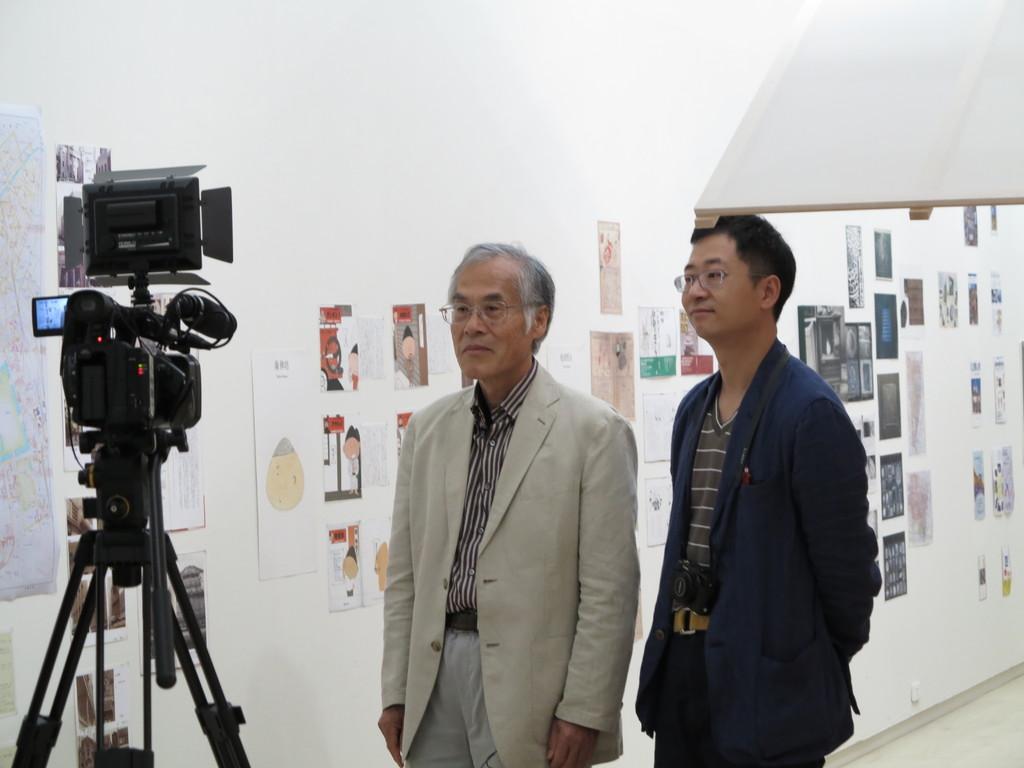How would you summarize this image in a sentence or two? In this image in the center there are two persons who are standing, and on the left side there is one camera. In the background there is a wall, on the wall there are some photos. On the top of the image there is a light and a board. 